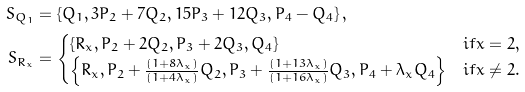Convert formula to latex. <formula><loc_0><loc_0><loc_500><loc_500>S _ { Q _ { 1 } } & = \left \{ Q _ { 1 } , 3 P _ { 2 } + 7 Q _ { 2 } , 1 5 P _ { 3 } + 1 2 Q _ { 3 } , P _ { 4 } - Q _ { 4 } \right \} , \\ S _ { R _ { x } } & = \begin{cases} \left \{ R _ { x } , P _ { 2 } + 2 Q _ { 2 } , P _ { 3 } + 2 Q _ { 3 } , Q _ { 4 } \right \} & i f x = 2 , \\ \left \{ R _ { x } , P _ { 2 } + \frac { ( 1 + 8 \lambda _ { x } ) } { ( 1 + 4 \lambda _ { x } ) } Q _ { 2 } , P _ { 3 } + \frac { ( 1 + 1 3 \lambda _ { x } ) } { ( 1 + 1 6 \lambda _ { x } ) } Q _ { 3 } , P _ { 4 } + \lambda _ { x } Q _ { 4 } \right \} & i f x \neq 2 . \\ \end{cases}</formula> 